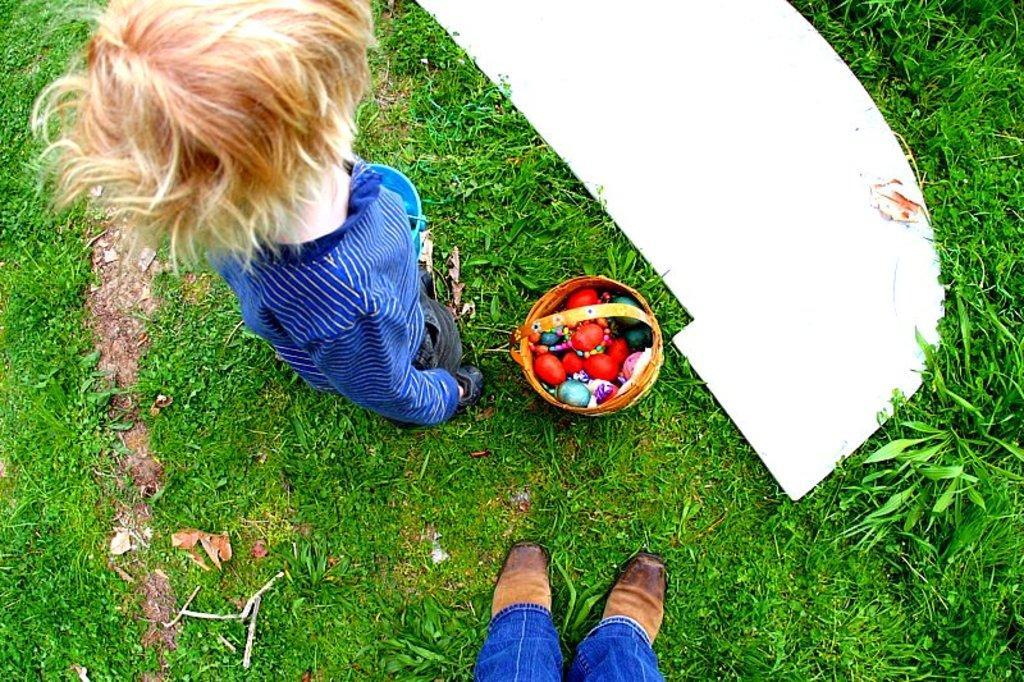Could you give a brief overview of what you see in this image? In this picture we can see a person, basket, shoes, clothes and some objects on the grass. 